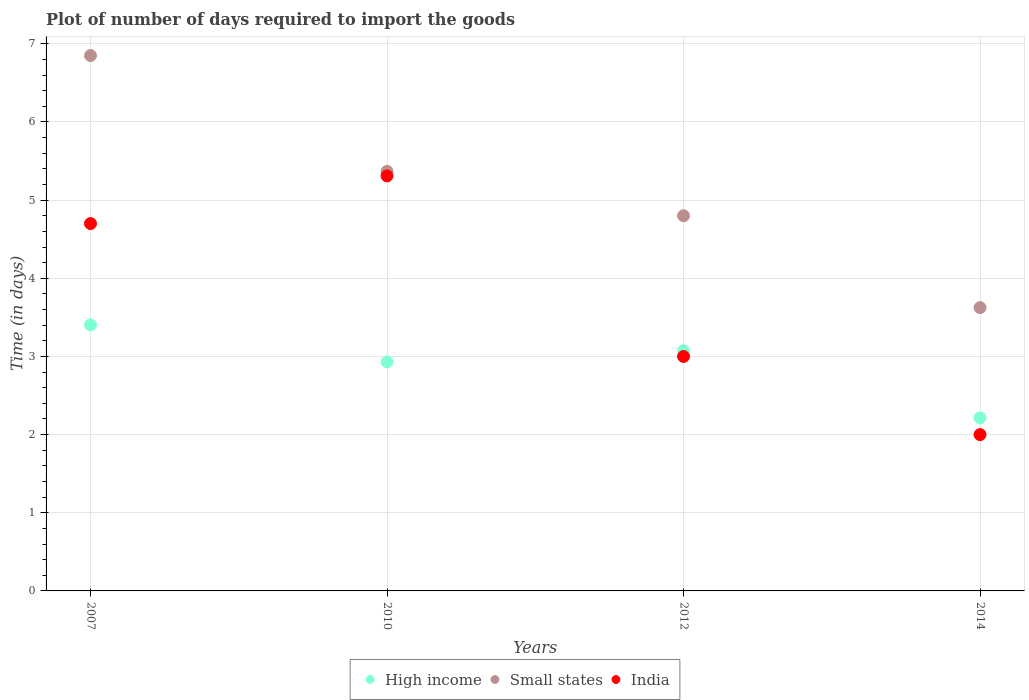Is the number of dotlines equal to the number of legend labels?
Provide a succinct answer. Yes. What is the time required to import goods in India in 2010?
Provide a succinct answer. 5.31. Across all years, what is the maximum time required to import goods in High income?
Your answer should be very brief. 3.4. Across all years, what is the minimum time required to import goods in Small states?
Your answer should be very brief. 3.62. In which year was the time required to import goods in High income minimum?
Your answer should be very brief. 2014. What is the total time required to import goods in High income in the graph?
Your response must be concise. 11.62. What is the difference between the time required to import goods in Small states in 2012 and that in 2014?
Ensure brevity in your answer.  1.17. What is the difference between the time required to import goods in High income in 2012 and the time required to import goods in Small states in 2007?
Your answer should be very brief. -3.78. What is the average time required to import goods in Small states per year?
Provide a succinct answer. 5.16. In the year 2012, what is the difference between the time required to import goods in Small states and time required to import goods in High income?
Provide a short and direct response. 1.73. In how many years, is the time required to import goods in India greater than 6.8 days?
Provide a succinct answer. 0. What is the ratio of the time required to import goods in India in 2007 to that in 2012?
Offer a terse response. 1.57. What is the difference between the highest and the second highest time required to import goods in High income?
Your response must be concise. 0.33. What is the difference between the highest and the lowest time required to import goods in India?
Keep it short and to the point. 3.31. In how many years, is the time required to import goods in High income greater than the average time required to import goods in High income taken over all years?
Provide a short and direct response. 3. Does the time required to import goods in High income monotonically increase over the years?
Give a very brief answer. No. Is the time required to import goods in High income strictly greater than the time required to import goods in Small states over the years?
Provide a short and direct response. No. How many dotlines are there?
Give a very brief answer. 3. How many years are there in the graph?
Provide a succinct answer. 4. Are the values on the major ticks of Y-axis written in scientific E-notation?
Provide a short and direct response. No. Does the graph contain any zero values?
Give a very brief answer. No. Does the graph contain grids?
Make the answer very short. Yes. How are the legend labels stacked?
Offer a terse response. Horizontal. What is the title of the graph?
Keep it short and to the point. Plot of number of days required to import the goods. Does "Turks and Caicos Islands" appear as one of the legend labels in the graph?
Make the answer very short. No. What is the label or title of the X-axis?
Provide a short and direct response. Years. What is the label or title of the Y-axis?
Make the answer very short. Time (in days). What is the Time (in days) of High income in 2007?
Keep it short and to the point. 3.4. What is the Time (in days) in Small states in 2007?
Make the answer very short. 6.85. What is the Time (in days) in High income in 2010?
Your answer should be very brief. 2.93. What is the Time (in days) of Small states in 2010?
Keep it short and to the point. 5.37. What is the Time (in days) of India in 2010?
Offer a very short reply. 5.31. What is the Time (in days) of High income in 2012?
Make the answer very short. 3.07. What is the Time (in days) in Small states in 2012?
Your response must be concise. 4.8. What is the Time (in days) of High income in 2014?
Give a very brief answer. 2.21. What is the Time (in days) in Small states in 2014?
Provide a succinct answer. 3.62. Across all years, what is the maximum Time (in days) of High income?
Make the answer very short. 3.4. Across all years, what is the maximum Time (in days) in Small states?
Provide a short and direct response. 6.85. Across all years, what is the maximum Time (in days) in India?
Offer a terse response. 5.31. Across all years, what is the minimum Time (in days) of High income?
Your response must be concise. 2.21. Across all years, what is the minimum Time (in days) in Small states?
Keep it short and to the point. 3.62. Across all years, what is the minimum Time (in days) in India?
Make the answer very short. 2. What is the total Time (in days) in High income in the graph?
Provide a succinct answer. 11.62. What is the total Time (in days) in Small states in the graph?
Ensure brevity in your answer.  20.64. What is the total Time (in days) of India in the graph?
Offer a terse response. 15.01. What is the difference between the Time (in days) in High income in 2007 and that in 2010?
Make the answer very short. 0.47. What is the difference between the Time (in days) in Small states in 2007 and that in 2010?
Make the answer very short. 1.48. What is the difference between the Time (in days) of India in 2007 and that in 2010?
Offer a terse response. -0.61. What is the difference between the Time (in days) of High income in 2007 and that in 2012?
Your answer should be very brief. 0.33. What is the difference between the Time (in days) of Small states in 2007 and that in 2012?
Provide a succinct answer. 2.05. What is the difference between the Time (in days) of High income in 2007 and that in 2014?
Provide a short and direct response. 1.19. What is the difference between the Time (in days) of Small states in 2007 and that in 2014?
Your answer should be very brief. 3.23. What is the difference between the Time (in days) in High income in 2010 and that in 2012?
Give a very brief answer. -0.14. What is the difference between the Time (in days) in Small states in 2010 and that in 2012?
Give a very brief answer. 0.57. What is the difference between the Time (in days) in India in 2010 and that in 2012?
Offer a terse response. 2.31. What is the difference between the Time (in days) of High income in 2010 and that in 2014?
Your answer should be very brief. 0.72. What is the difference between the Time (in days) in Small states in 2010 and that in 2014?
Provide a succinct answer. 1.74. What is the difference between the Time (in days) of India in 2010 and that in 2014?
Your answer should be compact. 3.31. What is the difference between the Time (in days) in High income in 2012 and that in 2014?
Ensure brevity in your answer.  0.86. What is the difference between the Time (in days) of Small states in 2012 and that in 2014?
Make the answer very short. 1.18. What is the difference between the Time (in days) of India in 2012 and that in 2014?
Provide a short and direct response. 1. What is the difference between the Time (in days) in High income in 2007 and the Time (in days) in Small states in 2010?
Provide a short and direct response. -1.96. What is the difference between the Time (in days) of High income in 2007 and the Time (in days) of India in 2010?
Keep it short and to the point. -1.91. What is the difference between the Time (in days) of Small states in 2007 and the Time (in days) of India in 2010?
Make the answer very short. 1.54. What is the difference between the Time (in days) of High income in 2007 and the Time (in days) of Small states in 2012?
Offer a terse response. -1.4. What is the difference between the Time (in days) in High income in 2007 and the Time (in days) in India in 2012?
Keep it short and to the point. 0.4. What is the difference between the Time (in days) in Small states in 2007 and the Time (in days) in India in 2012?
Your answer should be very brief. 3.85. What is the difference between the Time (in days) in High income in 2007 and the Time (in days) in Small states in 2014?
Provide a succinct answer. -0.22. What is the difference between the Time (in days) in High income in 2007 and the Time (in days) in India in 2014?
Your answer should be very brief. 1.4. What is the difference between the Time (in days) of Small states in 2007 and the Time (in days) of India in 2014?
Keep it short and to the point. 4.85. What is the difference between the Time (in days) in High income in 2010 and the Time (in days) in Small states in 2012?
Keep it short and to the point. -1.87. What is the difference between the Time (in days) in High income in 2010 and the Time (in days) in India in 2012?
Your answer should be very brief. -0.07. What is the difference between the Time (in days) of Small states in 2010 and the Time (in days) of India in 2012?
Provide a short and direct response. 2.37. What is the difference between the Time (in days) in High income in 2010 and the Time (in days) in Small states in 2014?
Your answer should be very brief. -0.69. What is the difference between the Time (in days) in High income in 2010 and the Time (in days) in India in 2014?
Ensure brevity in your answer.  0.93. What is the difference between the Time (in days) of Small states in 2010 and the Time (in days) of India in 2014?
Your answer should be very brief. 3.37. What is the difference between the Time (in days) of High income in 2012 and the Time (in days) of Small states in 2014?
Offer a very short reply. -0.55. What is the difference between the Time (in days) of High income in 2012 and the Time (in days) of India in 2014?
Your answer should be compact. 1.07. What is the average Time (in days) of High income per year?
Offer a very short reply. 2.91. What is the average Time (in days) in Small states per year?
Provide a succinct answer. 5.16. What is the average Time (in days) in India per year?
Offer a terse response. 3.75. In the year 2007, what is the difference between the Time (in days) of High income and Time (in days) of Small states?
Make the answer very short. -3.45. In the year 2007, what is the difference between the Time (in days) in High income and Time (in days) in India?
Provide a succinct answer. -1.3. In the year 2007, what is the difference between the Time (in days) of Small states and Time (in days) of India?
Your response must be concise. 2.15. In the year 2010, what is the difference between the Time (in days) in High income and Time (in days) in Small states?
Offer a terse response. -2.44. In the year 2010, what is the difference between the Time (in days) of High income and Time (in days) of India?
Give a very brief answer. -2.38. In the year 2010, what is the difference between the Time (in days) in Small states and Time (in days) in India?
Give a very brief answer. 0.06. In the year 2012, what is the difference between the Time (in days) in High income and Time (in days) in Small states?
Make the answer very short. -1.73. In the year 2012, what is the difference between the Time (in days) of High income and Time (in days) of India?
Your response must be concise. 0.07. In the year 2012, what is the difference between the Time (in days) of Small states and Time (in days) of India?
Offer a very short reply. 1.8. In the year 2014, what is the difference between the Time (in days) of High income and Time (in days) of Small states?
Offer a very short reply. -1.41. In the year 2014, what is the difference between the Time (in days) in High income and Time (in days) in India?
Offer a very short reply. 0.21. In the year 2014, what is the difference between the Time (in days) in Small states and Time (in days) in India?
Your answer should be compact. 1.62. What is the ratio of the Time (in days) in High income in 2007 to that in 2010?
Offer a terse response. 1.16. What is the ratio of the Time (in days) of Small states in 2007 to that in 2010?
Your answer should be very brief. 1.28. What is the ratio of the Time (in days) of India in 2007 to that in 2010?
Provide a succinct answer. 0.89. What is the ratio of the Time (in days) of High income in 2007 to that in 2012?
Make the answer very short. 1.11. What is the ratio of the Time (in days) in Small states in 2007 to that in 2012?
Offer a terse response. 1.43. What is the ratio of the Time (in days) in India in 2007 to that in 2012?
Offer a very short reply. 1.57. What is the ratio of the Time (in days) of High income in 2007 to that in 2014?
Offer a terse response. 1.54. What is the ratio of the Time (in days) in Small states in 2007 to that in 2014?
Offer a terse response. 1.89. What is the ratio of the Time (in days) of India in 2007 to that in 2014?
Provide a succinct answer. 2.35. What is the ratio of the Time (in days) of High income in 2010 to that in 2012?
Provide a short and direct response. 0.95. What is the ratio of the Time (in days) of Small states in 2010 to that in 2012?
Keep it short and to the point. 1.12. What is the ratio of the Time (in days) of India in 2010 to that in 2012?
Offer a terse response. 1.77. What is the ratio of the Time (in days) in High income in 2010 to that in 2014?
Give a very brief answer. 1.32. What is the ratio of the Time (in days) of Small states in 2010 to that in 2014?
Make the answer very short. 1.48. What is the ratio of the Time (in days) in India in 2010 to that in 2014?
Make the answer very short. 2.65. What is the ratio of the Time (in days) of High income in 2012 to that in 2014?
Your answer should be very brief. 1.39. What is the ratio of the Time (in days) of Small states in 2012 to that in 2014?
Ensure brevity in your answer.  1.32. What is the difference between the highest and the second highest Time (in days) of High income?
Make the answer very short. 0.33. What is the difference between the highest and the second highest Time (in days) in Small states?
Your answer should be very brief. 1.48. What is the difference between the highest and the second highest Time (in days) of India?
Make the answer very short. 0.61. What is the difference between the highest and the lowest Time (in days) of High income?
Ensure brevity in your answer.  1.19. What is the difference between the highest and the lowest Time (in days) in Small states?
Your answer should be compact. 3.23. What is the difference between the highest and the lowest Time (in days) in India?
Keep it short and to the point. 3.31. 